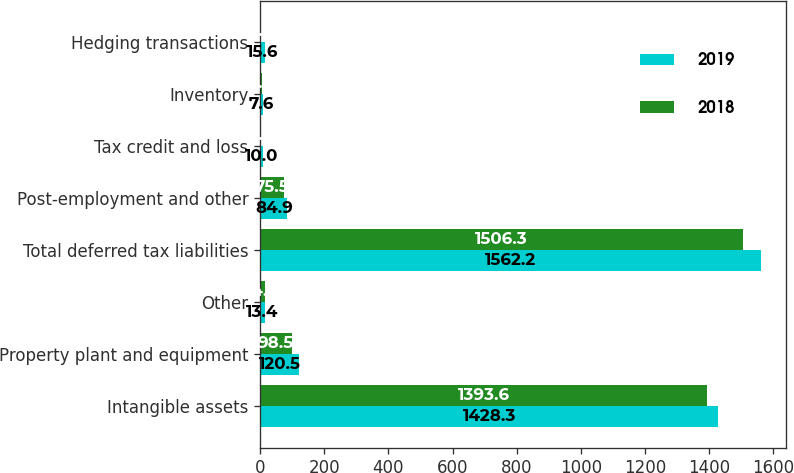Convert chart to OTSL. <chart><loc_0><loc_0><loc_500><loc_500><stacked_bar_chart><ecel><fcel>Intangible assets<fcel>Property plant and equipment<fcel>Other<fcel>Total deferred tax liabilities<fcel>Post-employment and other<fcel>Tax credit and loss<fcel>Inventory<fcel>Hedging transactions<nl><fcel>2019<fcel>1428.3<fcel>120.5<fcel>13.4<fcel>1562.2<fcel>84.9<fcel>10<fcel>7.6<fcel>15.6<nl><fcel>2018<fcel>1393.6<fcel>98.5<fcel>14.2<fcel>1506.3<fcel>75.5<fcel>0.2<fcel>5.9<fcel>0.9<nl></chart> 